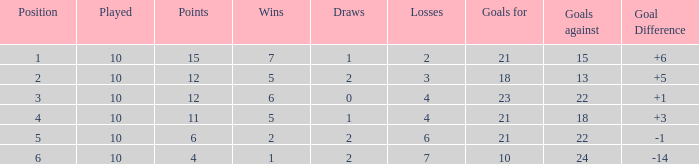Can you tell me the lowest Played that has the Position larger than 2, and the Draws smaller than 2, and the Goals against smaller than 18? None. 